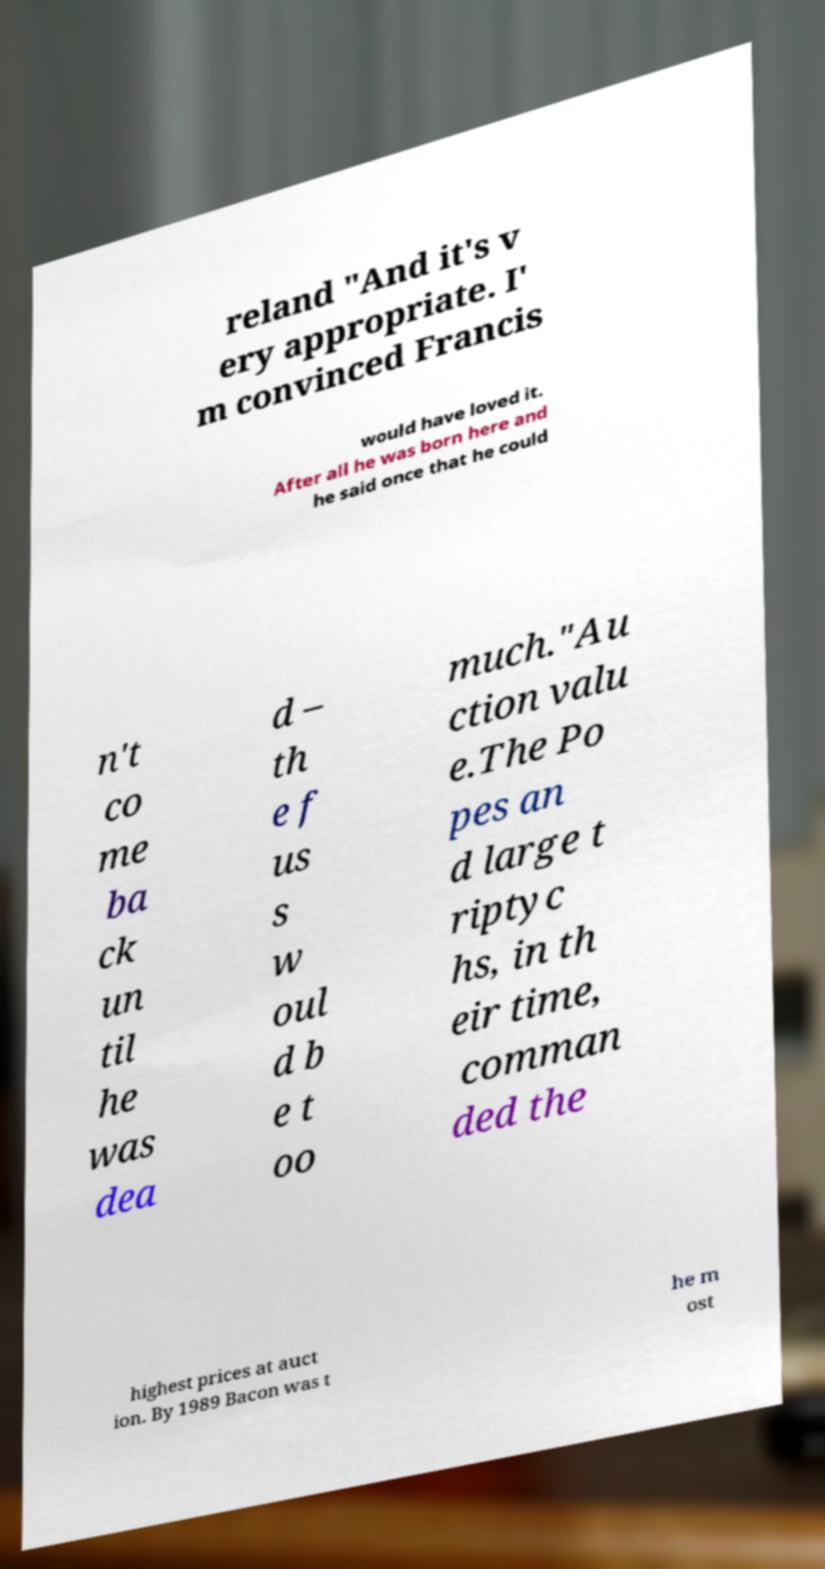What messages or text are displayed in this image? I need them in a readable, typed format. reland "And it's v ery appropriate. I' m convinced Francis would have loved it. After all he was born here and he said once that he could n't co me ba ck un til he was dea d – th e f us s w oul d b e t oo much."Au ction valu e.The Po pes an d large t riptyc hs, in th eir time, comman ded the highest prices at auct ion. By 1989 Bacon was t he m ost 